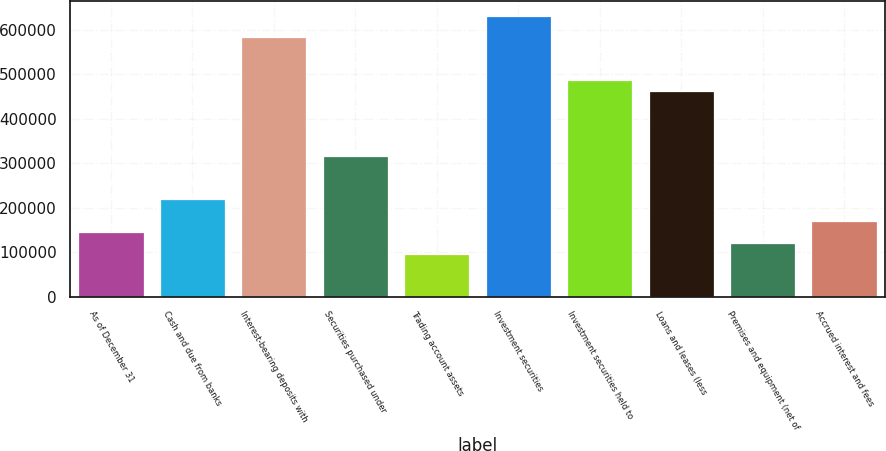Convert chart to OTSL. <chart><loc_0><loc_0><loc_500><loc_500><bar_chart><fcel>As of December 31<fcel>Cash and due from banks<fcel>Interest-bearing deposits with<fcel>Securities purchased under<fcel>Trading account assets<fcel>Investment securities<fcel>Investment securities held to<fcel>Loans and leases (less<fcel>Premises and equipment (net of<fcel>Accrued interest and fees<nl><fcel>145982<fcel>218964<fcel>583872<fcel>316273<fcel>97327.8<fcel>632526<fcel>486563<fcel>462236<fcel>121655<fcel>170309<nl></chart> 